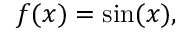<formula> <loc_0><loc_0><loc_500><loc_500>f ( x ) = \sin ( x ) ,</formula> 